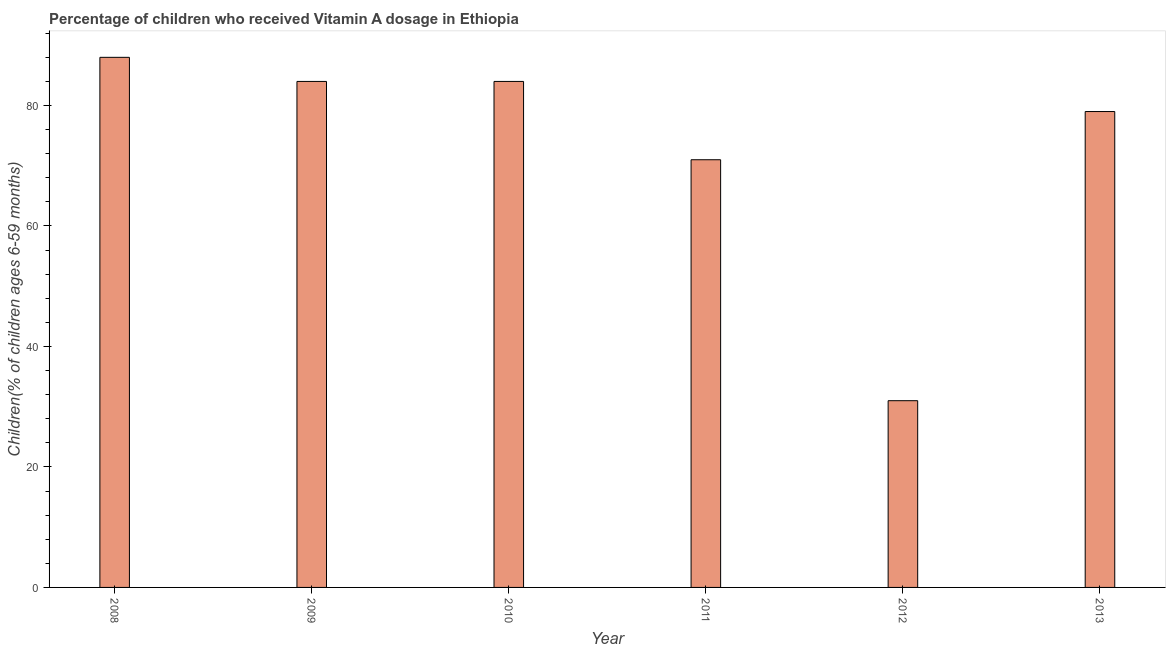Does the graph contain grids?
Your response must be concise. No. What is the title of the graph?
Keep it short and to the point. Percentage of children who received Vitamin A dosage in Ethiopia. What is the label or title of the X-axis?
Give a very brief answer. Year. What is the label or title of the Y-axis?
Make the answer very short. Children(% of children ages 6-59 months). What is the sum of the vitamin a supplementation coverage rate?
Your answer should be very brief. 437. What is the median vitamin a supplementation coverage rate?
Your answer should be very brief. 81.5. In how many years, is the vitamin a supplementation coverage rate greater than 52 %?
Provide a short and direct response. 5. What is the ratio of the vitamin a supplementation coverage rate in 2009 to that in 2013?
Ensure brevity in your answer.  1.06. Is the difference between the vitamin a supplementation coverage rate in 2012 and 2013 greater than the difference between any two years?
Your answer should be very brief. No. Are all the bars in the graph horizontal?
Provide a short and direct response. No. What is the Children(% of children ages 6-59 months) of 2008?
Your answer should be compact. 88. What is the Children(% of children ages 6-59 months) in 2009?
Keep it short and to the point. 84. What is the Children(% of children ages 6-59 months) in 2010?
Your answer should be very brief. 84. What is the Children(% of children ages 6-59 months) in 2011?
Keep it short and to the point. 71. What is the Children(% of children ages 6-59 months) of 2013?
Provide a succinct answer. 79. What is the difference between the Children(% of children ages 6-59 months) in 2008 and 2012?
Give a very brief answer. 57. What is the difference between the Children(% of children ages 6-59 months) in 2009 and 2012?
Offer a terse response. 53. What is the difference between the Children(% of children ages 6-59 months) in 2009 and 2013?
Provide a short and direct response. 5. What is the difference between the Children(% of children ages 6-59 months) in 2010 and 2011?
Your response must be concise. 13. What is the difference between the Children(% of children ages 6-59 months) in 2010 and 2012?
Keep it short and to the point. 53. What is the difference between the Children(% of children ages 6-59 months) in 2010 and 2013?
Give a very brief answer. 5. What is the difference between the Children(% of children ages 6-59 months) in 2011 and 2012?
Your answer should be very brief. 40. What is the difference between the Children(% of children ages 6-59 months) in 2012 and 2013?
Your answer should be compact. -48. What is the ratio of the Children(% of children ages 6-59 months) in 2008 to that in 2009?
Provide a short and direct response. 1.05. What is the ratio of the Children(% of children ages 6-59 months) in 2008 to that in 2010?
Provide a succinct answer. 1.05. What is the ratio of the Children(% of children ages 6-59 months) in 2008 to that in 2011?
Make the answer very short. 1.24. What is the ratio of the Children(% of children ages 6-59 months) in 2008 to that in 2012?
Your answer should be very brief. 2.84. What is the ratio of the Children(% of children ages 6-59 months) in 2008 to that in 2013?
Provide a succinct answer. 1.11. What is the ratio of the Children(% of children ages 6-59 months) in 2009 to that in 2011?
Your response must be concise. 1.18. What is the ratio of the Children(% of children ages 6-59 months) in 2009 to that in 2012?
Give a very brief answer. 2.71. What is the ratio of the Children(% of children ages 6-59 months) in 2009 to that in 2013?
Make the answer very short. 1.06. What is the ratio of the Children(% of children ages 6-59 months) in 2010 to that in 2011?
Make the answer very short. 1.18. What is the ratio of the Children(% of children ages 6-59 months) in 2010 to that in 2012?
Offer a terse response. 2.71. What is the ratio of the Children(% of children ages 6-59 months) in 2010 to that in 2013?
Keep it short and to the point. 1.06. What is the ratio of the Children(% of children ages 6-59 months) in 2011 to that in 2012?
Provide a short and direct response. 2.29. What is the ratio of the Children(% of children ages 6-59 months) in 2011 to that in 2013?
Provide a succinct answer. 0.9. What is the ratio of the Children(% of children ages 6-59 months) in 2012 to that in 2013?
Make the answer very short. 0.39. 